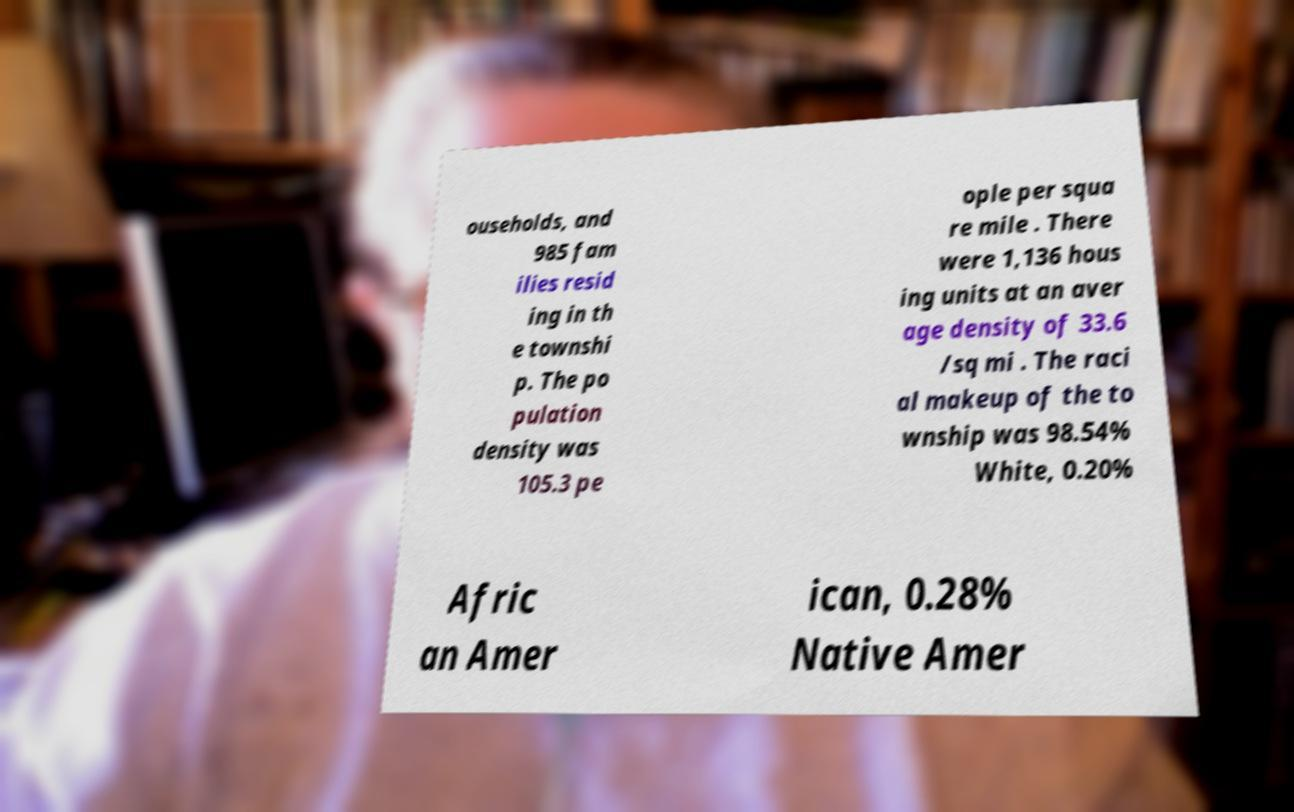There's text embedded in this image that I need extracted. Can you transcribe it verbatim? ouseholds, and 985 fam ilies resid ing in th e townshi p. The po pulation density was 105.3 pe ople per squa re mile . There were 1,136 hous ing units at an aver age density of 33.6 /sq mi . The raci al makeup of the to wnship was 98.54% White, 0.20% Afric an Amer ican, 0.28% Native Amer 